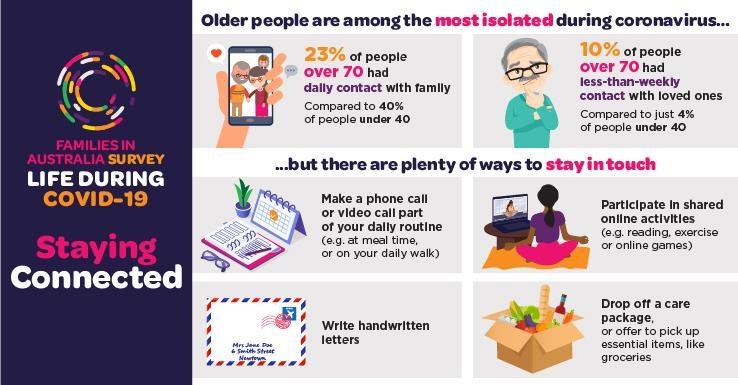What percent of Australians aged under 40 had daily contact with their families during COVID-19 time?
Answer the question with a short phrase. 40% What percent of Australians aged under 40 had less than weekly contact with their families during COVID-19 time? 4% What percent of Australians aged over 70 do not had daily contact with their families during COVID-19 time? 77% 